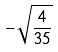<formula> <loc_0><loc_0><loc_500><loc_500>- \sqrt { \frac { 4 } { 3 5 } }</formula> 